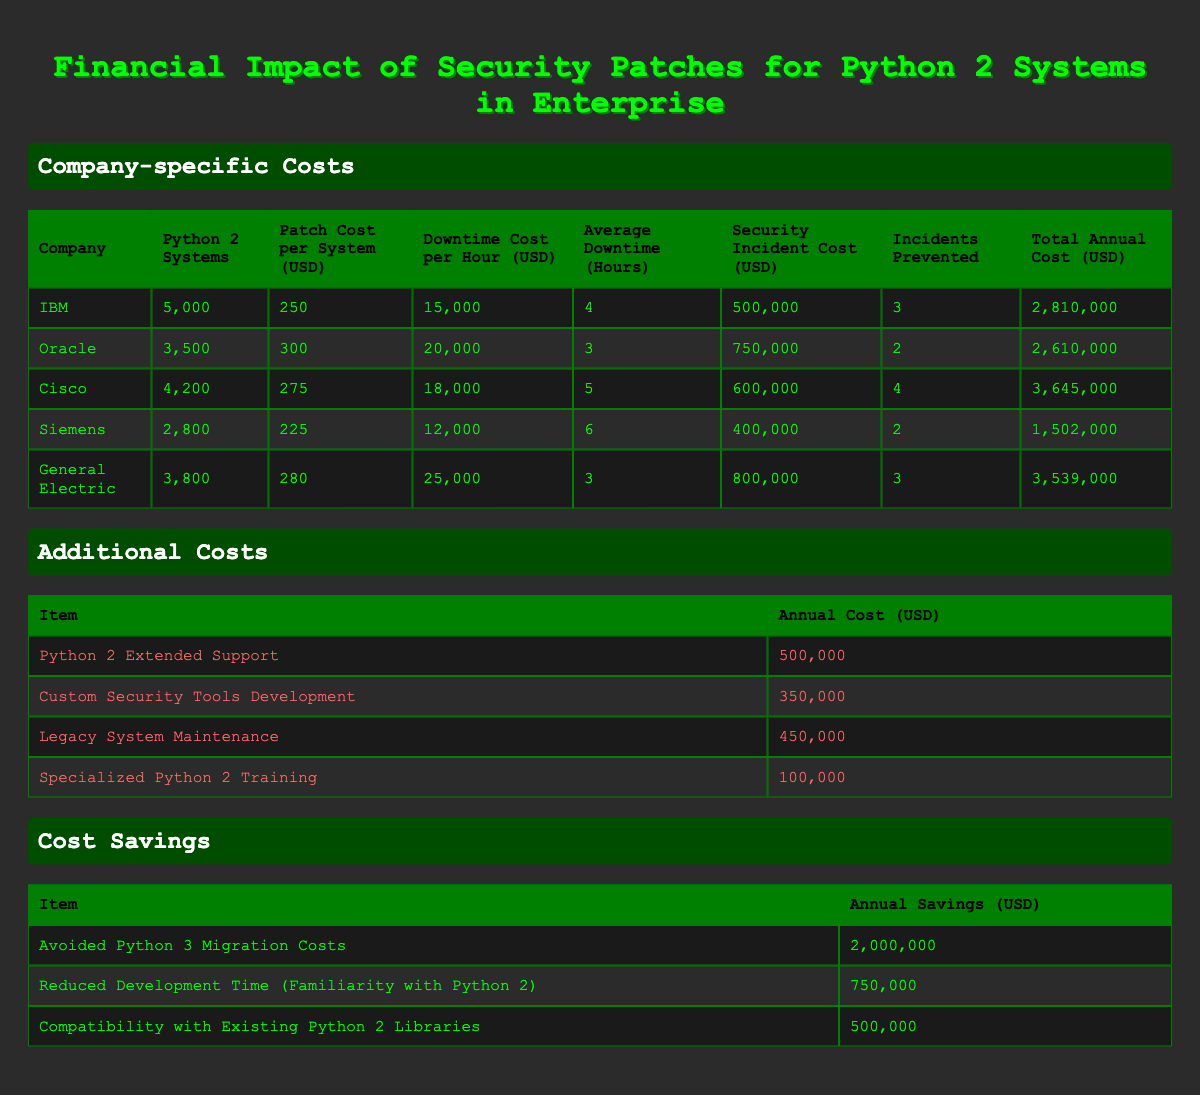What is the total annual cost for IBM's Python 2 systems? To find the total annual cost for IBM, we look at the relevant row in the table. The table indicates that IBM has a total annual cost of 2,810,000 USD.
Answer: 2,810,000 Which company has the highest downtime cost per hour? The table shows the downtime costs per hour for each company. Looking through the values, General Electric has the highest downtime cost at 25,000 USD per hour.
Answer: General Electric What is the total patch cost for Cisco's Python 2 systems? To determine the total patch cost for Cisco, we multiply the number of systems (4,200) by the patch cost per system (275). The calculation is 4,200 * 275 = 1,155,000 USD.
Answer: 1,155,000 Did Oracle prevent more security incidents than Siemens? We can check the number of incidents prevented by both Oracle and Siemens in the table. Oracle prevented 2 incidents, while Siemens also prevented 2 incidents. Therefore, they both prevented the same number of incidents.
Answer: No What is the combined total annual cost for all listed additional costs? To find the combined total annual cost of all additional costs, we sum the individual items: 500,000 (Extended Support) + 350,000 (Security Tools) + 450,000 (System Maintenance) + 100,000 (Training) = 1,400,000 USD.
Answer: 1,400,000 Which company had the lowest total annual cost and what was that cost? By inspecting the total annual costs for each company, we find Siemens has the lowest total at 1,872,000 USD.
Answer: 1,872,000 What is the average cost savings from all listed items? To find the average cost savings, we first sum the annual savings: 2,000,000 + 750,000 + 500,000 = 3,250,000 USD. There are 3 items, so the average is 3,250,000 / 3 = 1,083,333.33 USD.
Answer: 1,083,333.33 How much did Cisco save from avoiding Python 3 migration costs compared to Siemens? Cisco saved 2,000,000 USD from avoiding migration costs compared to Siemens, which saves nothing in this category. The difference is 2,000,000 - 0 = 2,000,000 USD.
Answer: 2,000,000 Did any company spend less on patch costs than the security incident costs they prevented? For each company, we compare patch costs against corresponding security incident costs prevented. For IBM (250,000 < 1,500,000), Oracle (1,050,000 < 1,500,000), Cisco (1,155,000 < 2,400,000), Siemens (630,000 < 800,000), and General Electric (1,064,000 < 2,400,000). All companies spent less on patch costs than they saved from prevented incidents.
Answer: Yes 